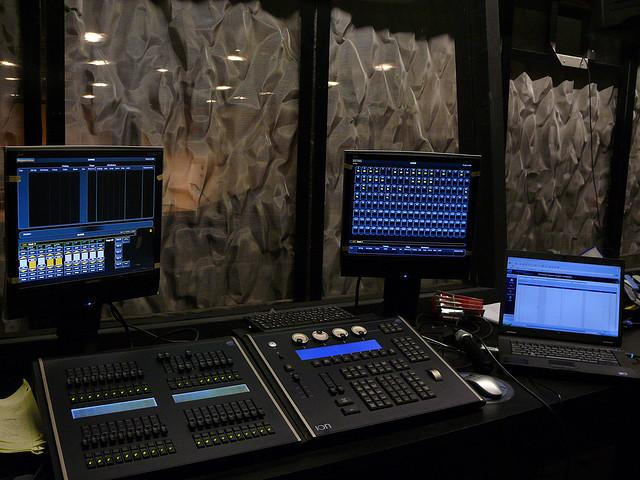The sliders on the equipment on the desk is used to adjust what?

Choices:
A) lighting
B) sound
C) temperature
D) blinds lighting 